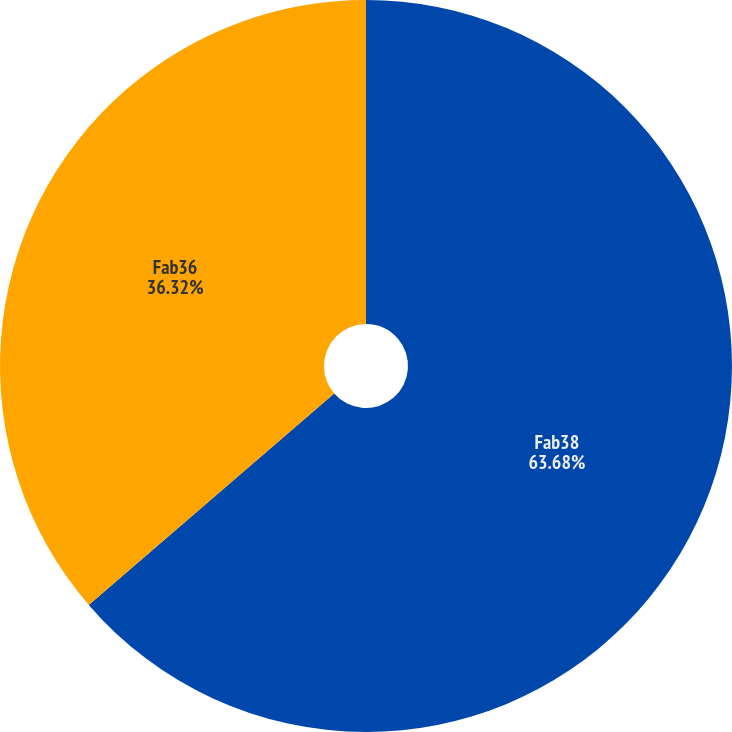<chart> <loc_0><loc_0><loc_500><loc_500><pie_chart><fcel>Fab38<fcel>Fab36<nl><fcel>63.68%<fcel>36.32%<nl></chart> 